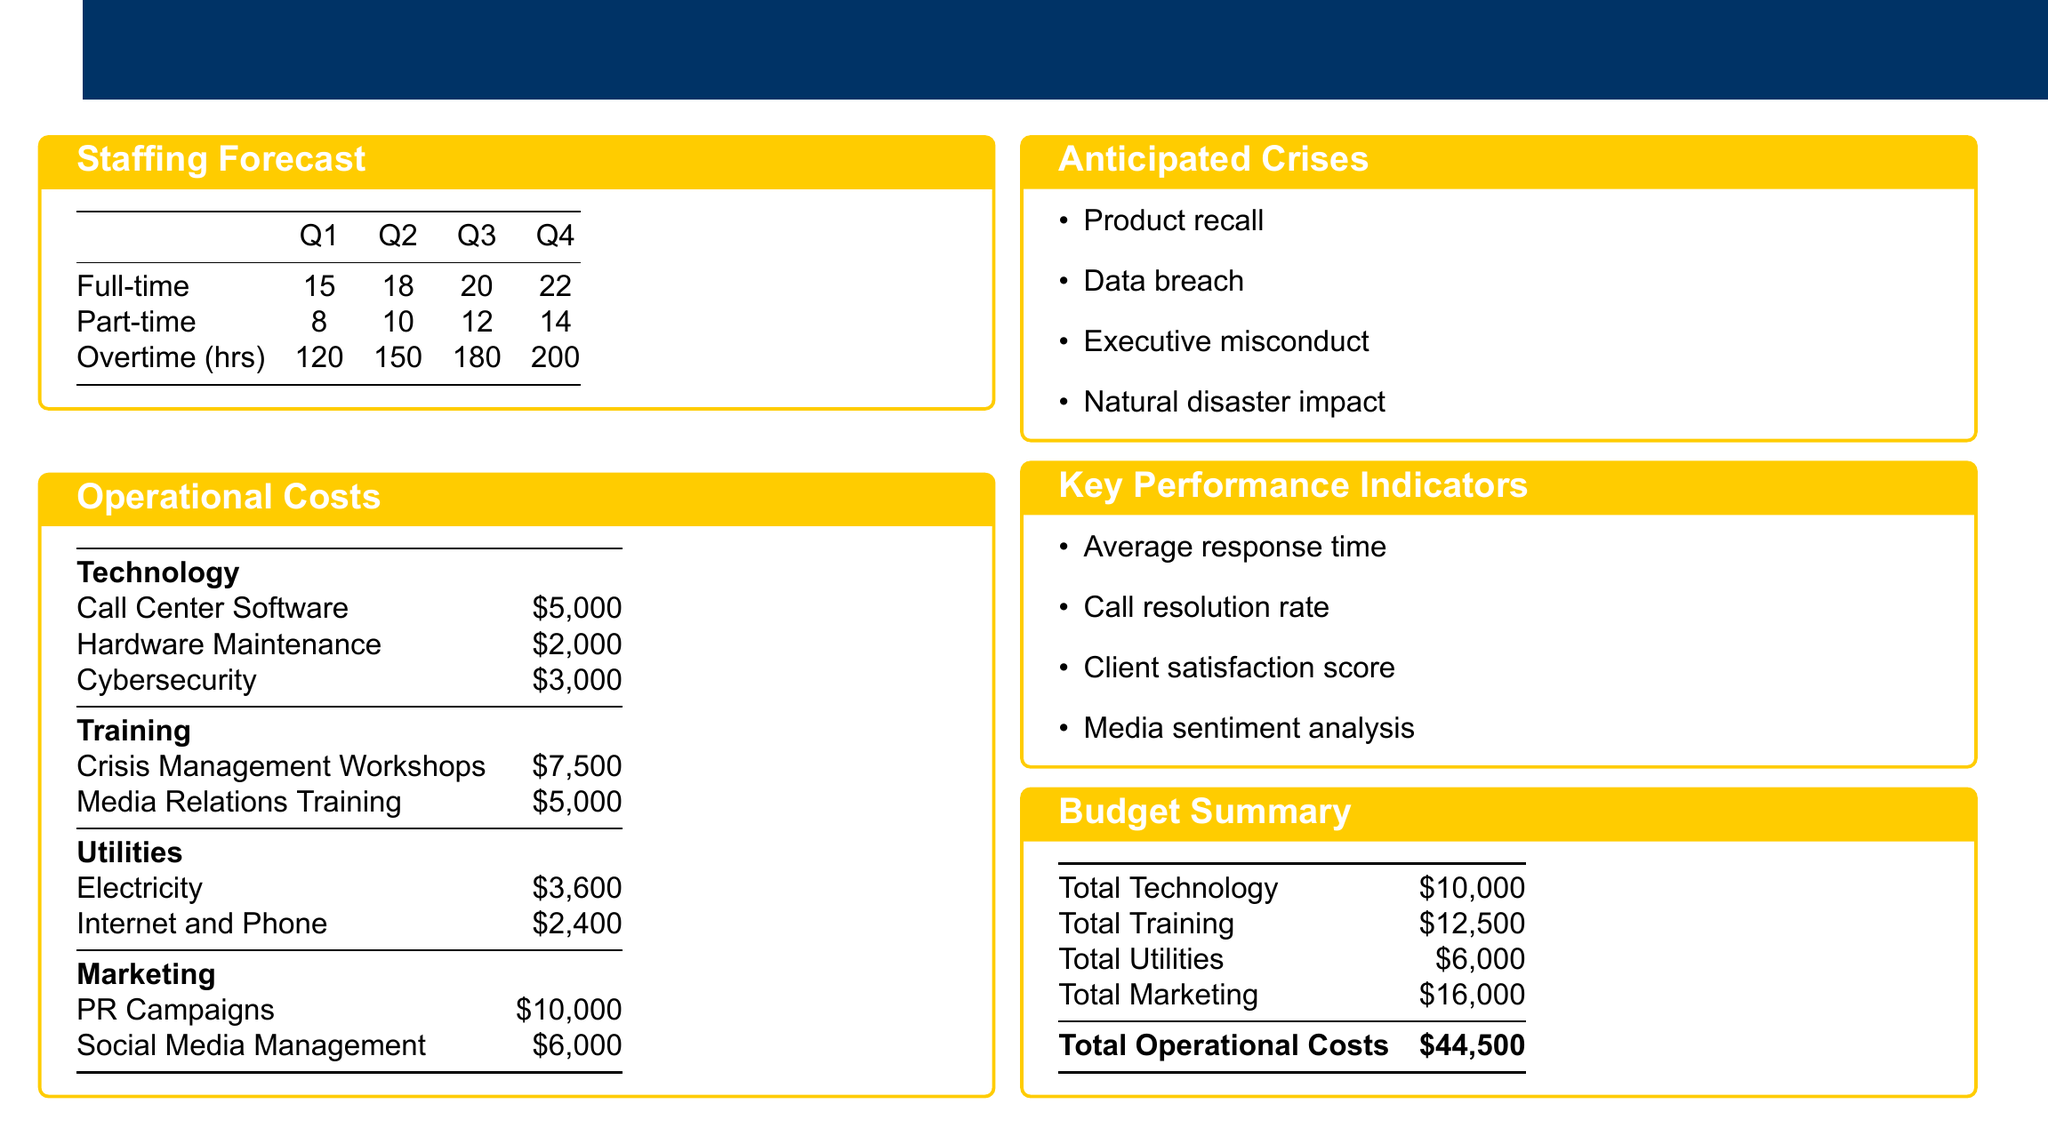What is the total operational costs? The total operational costs are outlined in the budget summary, which combines all expenses listed.
Answer: $44,500 How many full-time staff members are planned for Q3? The staffing forecast table details the number of full-time employees, which states 20 for Q3.
Answer: 20 What is the cost for Cybersecurity? The operational costs section lists Cybersecurity under Technology with its specific expense.
Answer: $3,000 What is the total cost for Training? The budget summary includes a total for Training, which is the sum of all training-related expenses.
Answer: $12,500 Which anticipated crisis is listed first? The anticipated crises box enumerates the potential crises, with a product recall mentioned first.
Answer: Product recall How many part-time staff members are there in Q2? The staffing forecast section provides the number of part-time staff, indicating 10 for Q2.
Answer: 10 What is the cost for Social Media Management? The operational costs list includes Social Media Management under Marketing with its specific expense.
Answer: $6,000 What are the key performance indicators mentioned? The key performance indicators box outlines several metrics important for assessing hotline performance.
Answer: Average response time, Call resolution rate, Client satisfaction score, Media sentiment analysis 